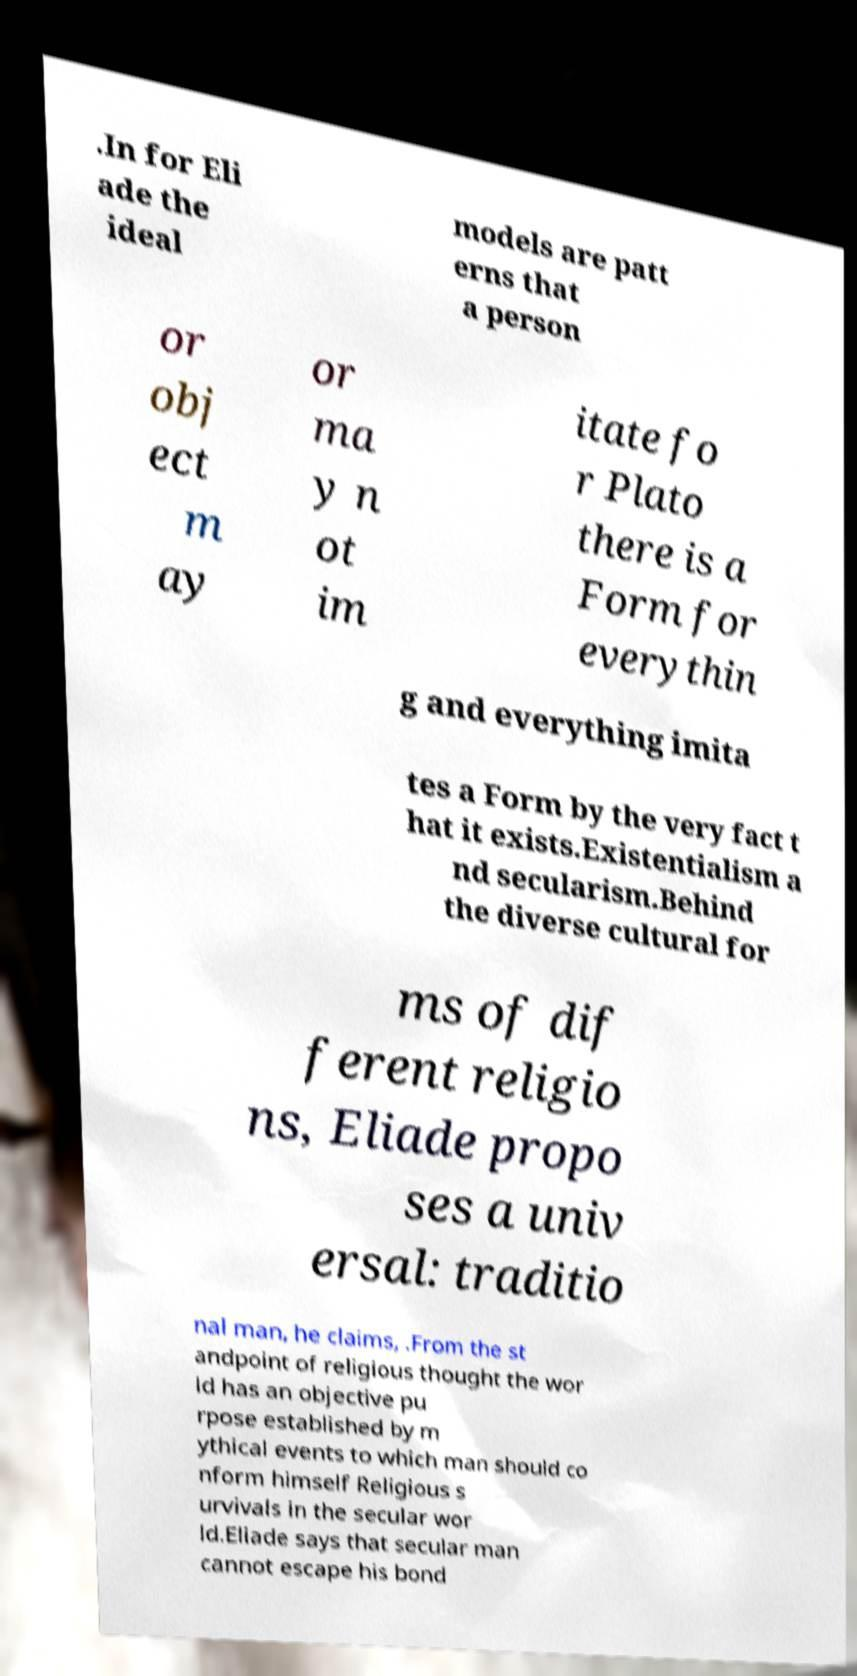Could you assist in decoding the text presented in this image and type it out clearly? .In for Eli ade the ideal models are patt erns that a person or obj ect m ay or ma y n ot im itate fo r Plato there is a Form for everythin g and everything imita tes a Form by the very fact t hat it exists.Existentialism a nd secularism.Behind the diverse cultural for ms of dif ferent religio ns, Eliade propo ses a univ ersal: traditio nal man, he claims, .From the st andpoint of religious thought the wor ld has an objective pu rpose established by m ythical events to which man should co nform himself Religious s urvivals in the secular wor ld.Eliade says that secular man cannot escape his bond 